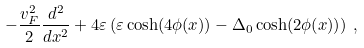Convert formula to latex. <formula><loc_0><loc_0><loc_500><loc_500>- \frac { v _ { F } ^ { 2 } } { 2 } \frac { d ^ { 2 } } { d x ^ { 2 } } + 4 \varepsilon \left ( \varepsilon \cosh ( 4 \phi ( x ) ) - \Delta _ { 0 } \cosh ( 2 \phi ( x ) ) \right ) \, ,</formula> 